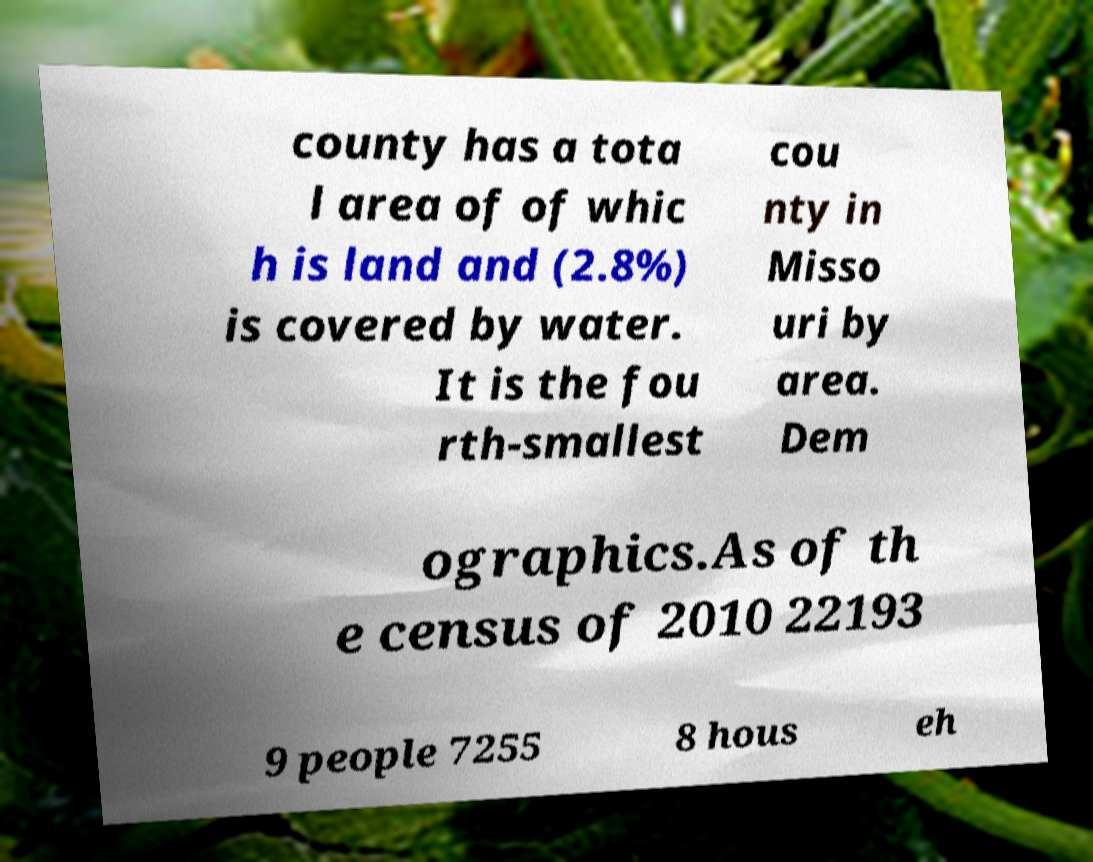Can you accurately transcribe the text from the provided image for me? county has a tota l area of of whic h is land and (2.8%) is covered by water. It is the fou rth-smallest cou nty in Misso uri by area. Dem ographics.As of th e census of 2010 22193 9 people 7255 8 hous eh 